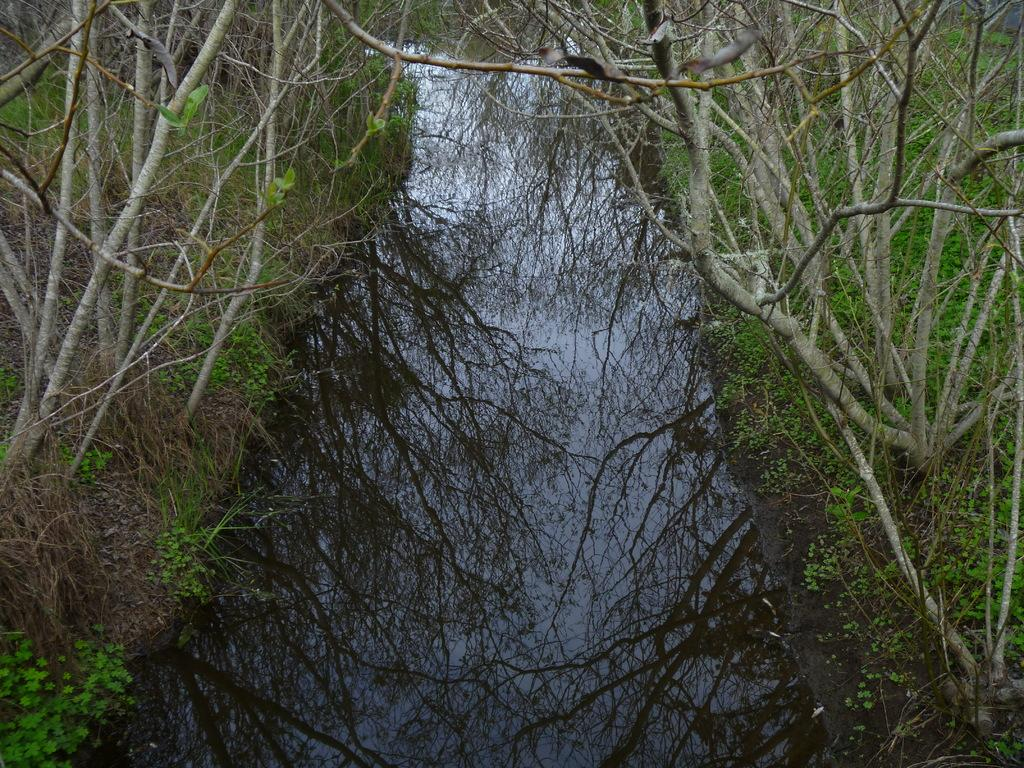What is located in the middle of the image? There is water in the middle of the image. What type of vegetation can be seen in the image? There are trees in the image. What date is marked on the calendar in the image? There is no calendar present in the image. Is it raining in the image? The provided facts do not mention rain, so we cannot determine if it is raining in the image. 